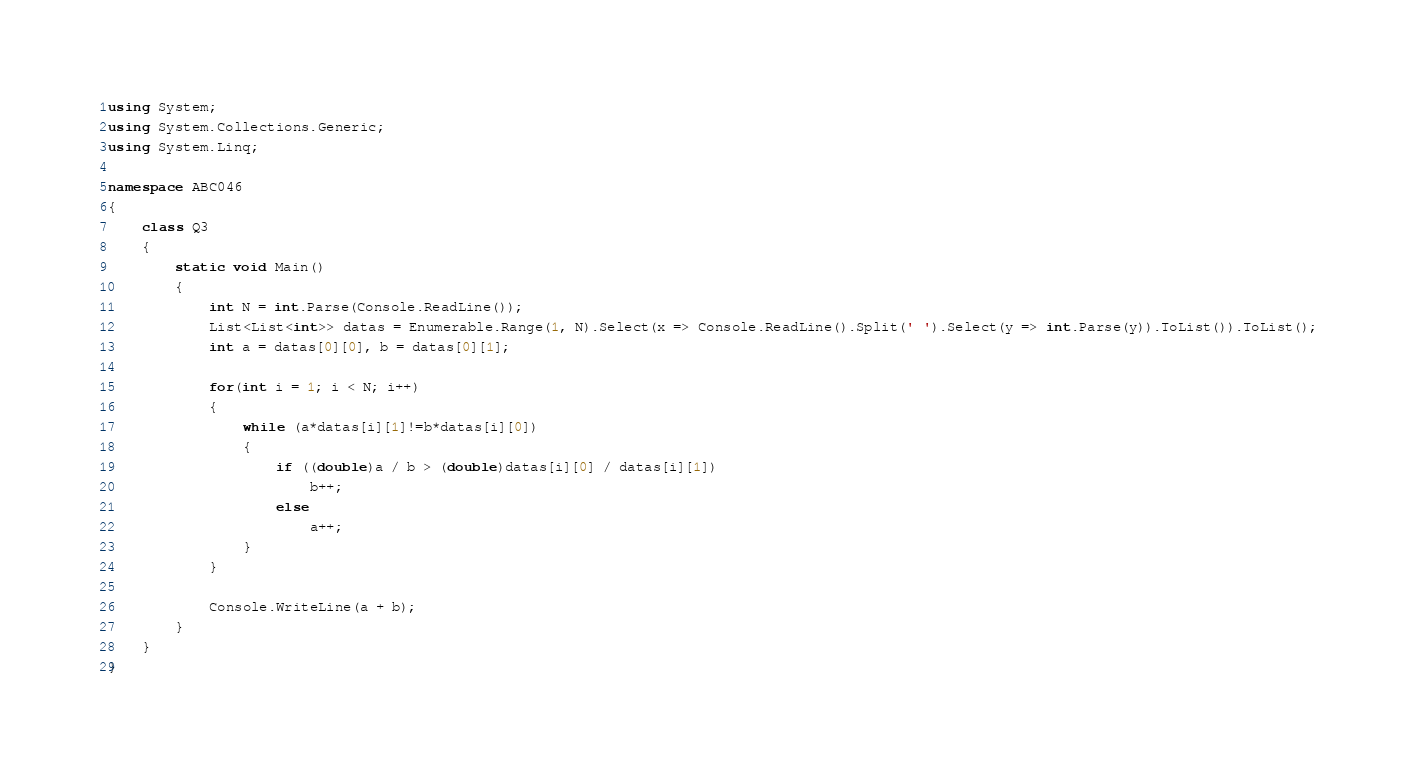Convert code to text. <code><loc_0><loc_0><loc_500><loc_500><_C#_>using System;
using System.Collections.Generic;
using System.Linq;

namespace ABC046
{
	class Q3
	{
		static void Main()
		{
			int N = int.Parse(Console.ReadLine());
			List<List<int>> datas = Enumerable.Range(1, N).Select(x => Console.ReadLine().Split(' ').Select(y => int.Parse(y)).ToList()).ToList();
			int a = datas[0][0], b = datas[0][1];

			for(int i = 1; i < N; i++)
			{
				while (a*datas[i][1]!=b*datas[i][0])
				{
					if ((double)a / b > (double)datas[i][0] / datas[i][1])
						b++;
					else
						a++;
				}
			}

			Console.WriteLine(a + b);
		}
	}
}
</code> 